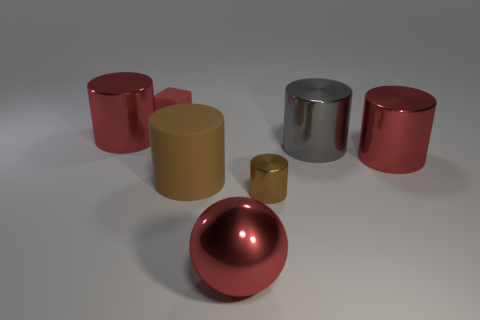Subtract all brown blocks. How many red cylinders are left? 2 Subtract all large red metal cylinders. How many cylinders are left? 3 Subtract all red cylinders. How many cylinders are left? 3 Add 2 cyan matte cylinders. How many objects exist? 9 Subtract all gray cylinders. Subtract all gray balls. How many cylinders are left? 4 Subtract all blocks. How many objects are left? 6 Subtract all large cylinders. Subtract all brown rubber things. How many objects are left? 2 Add 4 spheres. How many spheres are left? 5 Add 3 tiny red matte cubes. How many tiny red matte cubes exist? 4 Subtract 0 blue blocks. How many objects are left? 7 